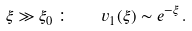Convert formula to latex. <formula><loc_0><loc_0><loc_500><loc_500>\xi \gg \xi _ { 0 } \, \colon \quad v _ { 1 } ( \xi ) \sim e ^ { - \xi } \, .</formula> 